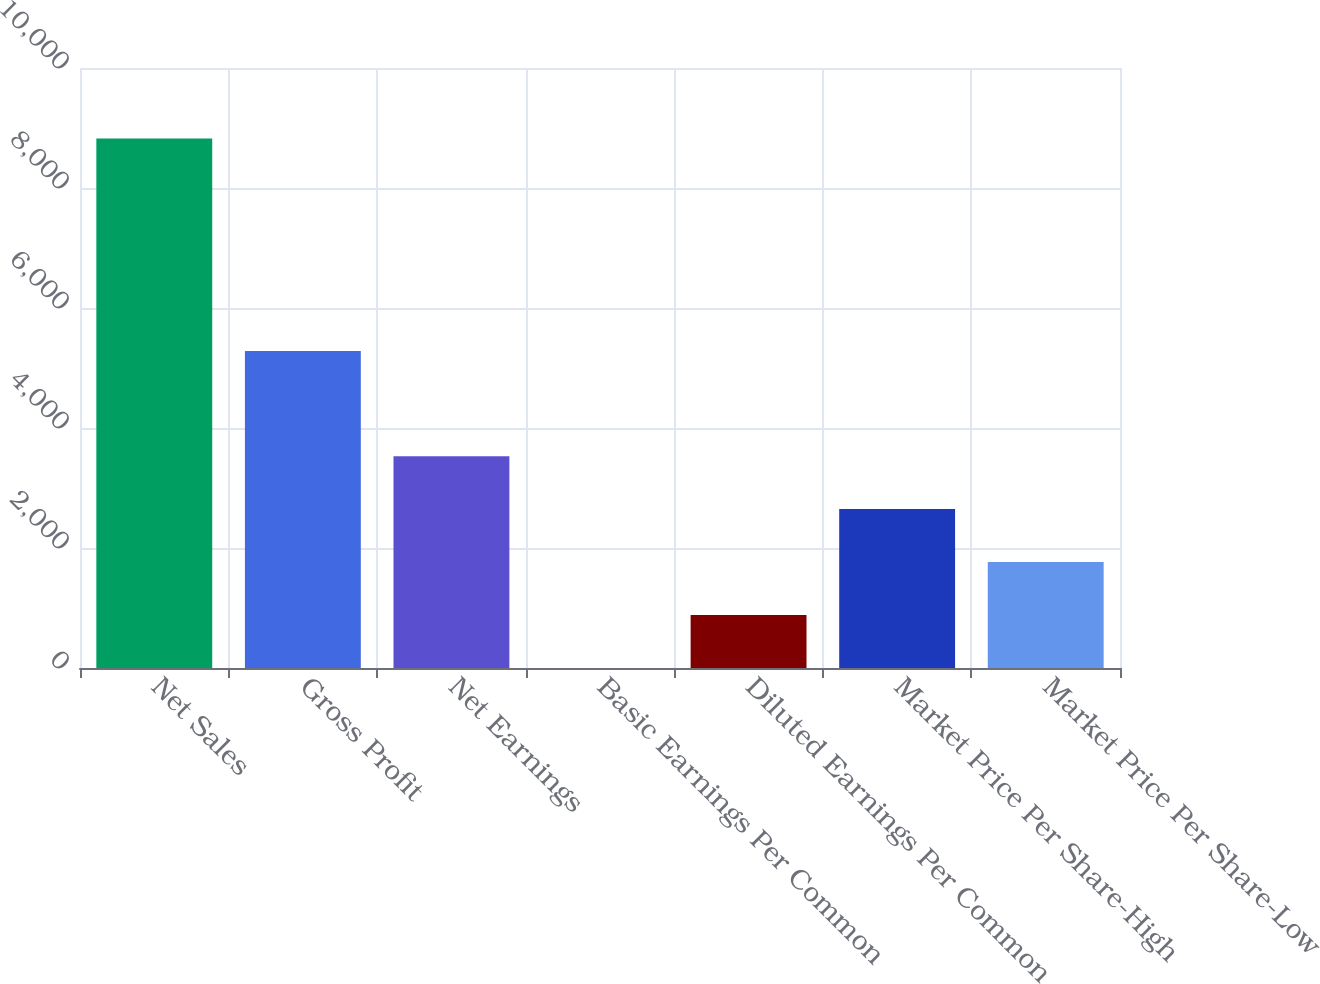<chart> <loc_0><loc_0><loc_500><loc_500><bar_chart><fcel>Net Sales<fcel>Gross Profit<fcel>Net Earnings<fcel>Basic Earnings Per Common<fcel>Diluted Earnings Per Common<fcel>Market Price Per Share-High<fcel>Market Price Per Share-Low<nl><fcel>8826<fcel>5282.1<fcel>3530.91<fcel>0.83<fcel>883.35<fcel>2648.39<fcel>1765.87<nl></chart> 